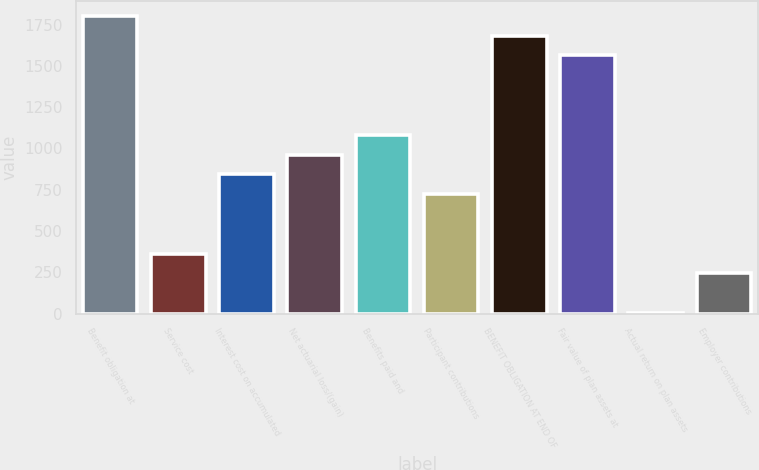<chart> <loc_0><loc_0><loc_500><loc_500><bar_chart><fcel>Benefit obligation at<fcel>Service cost<fcel>Interest cost on accumulated<fcel>Net actuarial loss/(gain)<fcel>Benefits paid and<fcel>Participant contributions<fcel>BENEFIT OBLIGATION AT END OF<fcel>Fair value of plan assets at<fcel>Actual return on plan assets<fcel>Employer contributions<nl><fcel>1802.5<fcel>363.7<fcel>843.3<fcel>963.2<fcel>1083.1<fcel>723.4<fcel>1682.6<fcel>1562.7<fcel>4<fcel>243.8<nl></chart> 